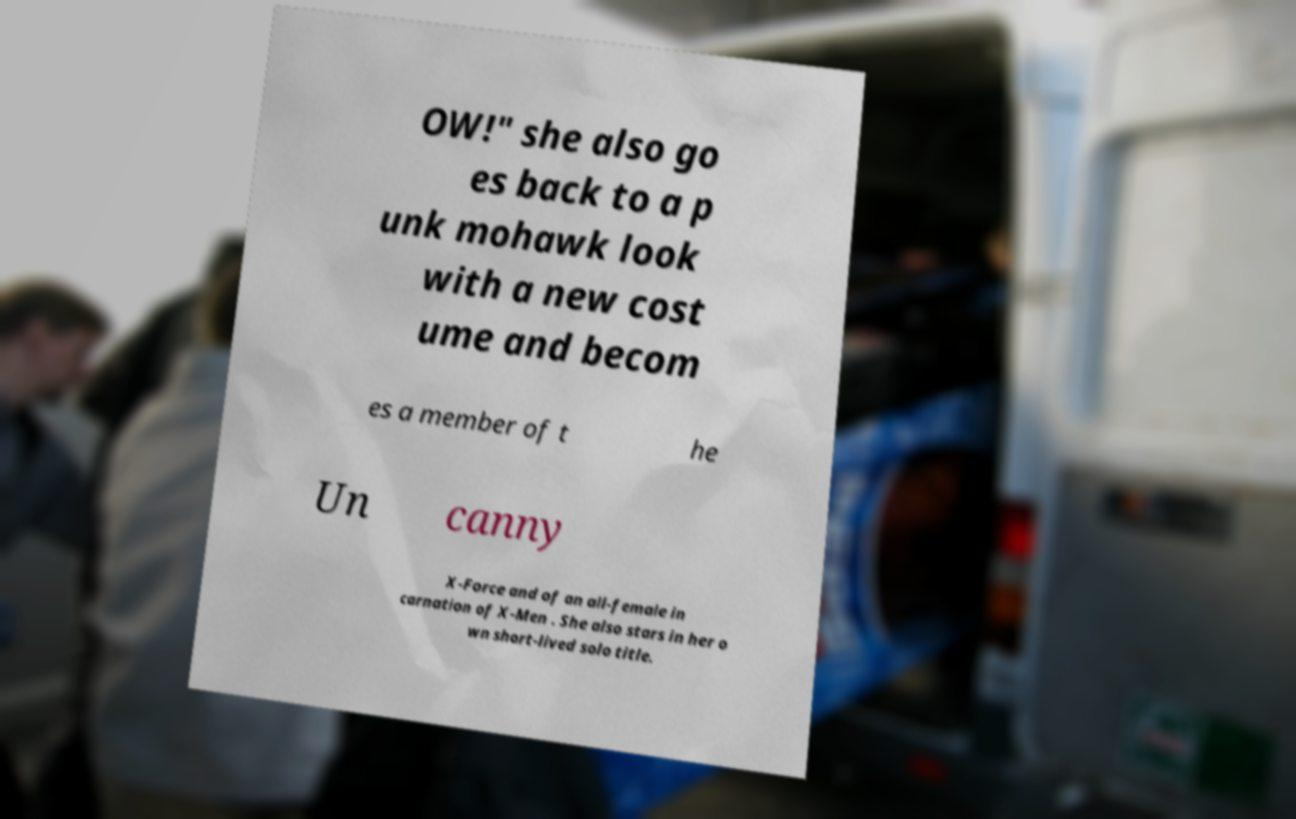Can you accurately transcribe the text from the provided image for me? OW!" she also go es back to a p unk mohawk look with a new cost ume and becom es a member of t he Un canny X-Force and of an all-female in carnation of X-Men . She also stars in her o wn short-lived solo title. 